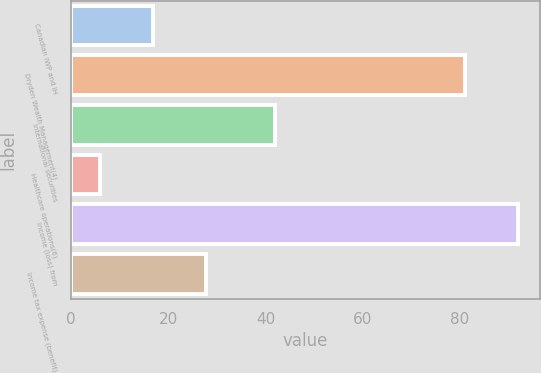Convert chart. <chart><loc_0><loc_0><loc_500><loc_500><bar_chart><fcel>Canadian IWP and IH<fcel>Dryden Wealth Management(4)<fcel>International securities<fcel>Healthcare operations(6)<fcel>Income (loss) from<fcel>Income tax expense (benefit)<nl><fcel>16.9<fcel>81<fcel>42<fcel>6<fcel>91.9<fcel>27.8<nl></chart> 